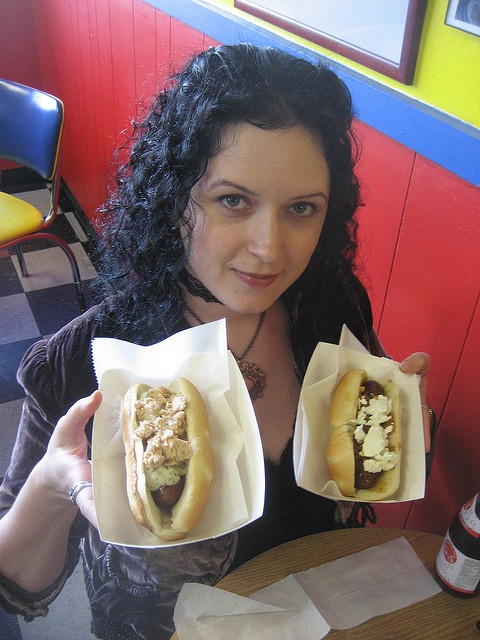Describe the objects in this image and their specific colors. I can see people in brown, black, gray, and tan tones, hot dog in brown, tan, and ivory tones, chair in brown, black, blue, navy, and gray tones, hot dog in brown, tan, khaki, and olive tones, and dining table in brown, maroon, black, and gray tones in this image. 